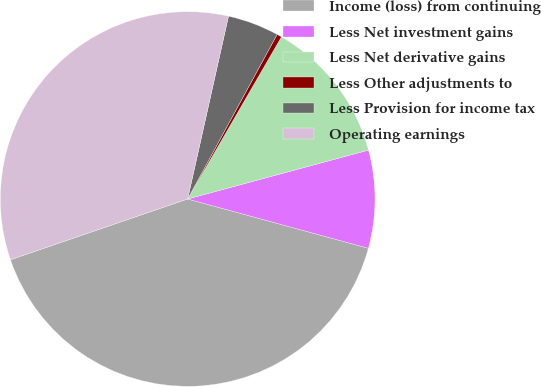<chart> <loc_0><loc_0><loc_500><loc_500><pie_chart><fcel>Income (loss) from continuing<fcel>Less Net investment gains<fcel>Less Net derivative gains<fcel>Less Other adjustments to<fcel>Less Provision for income tax<fcel>Operating earnings<nl><fcel>40.51%<fcel>8.44%<fcel>12.45%<fcel>0.42%<fcel>4.43%<fcel>33.76%<nl></chart> 